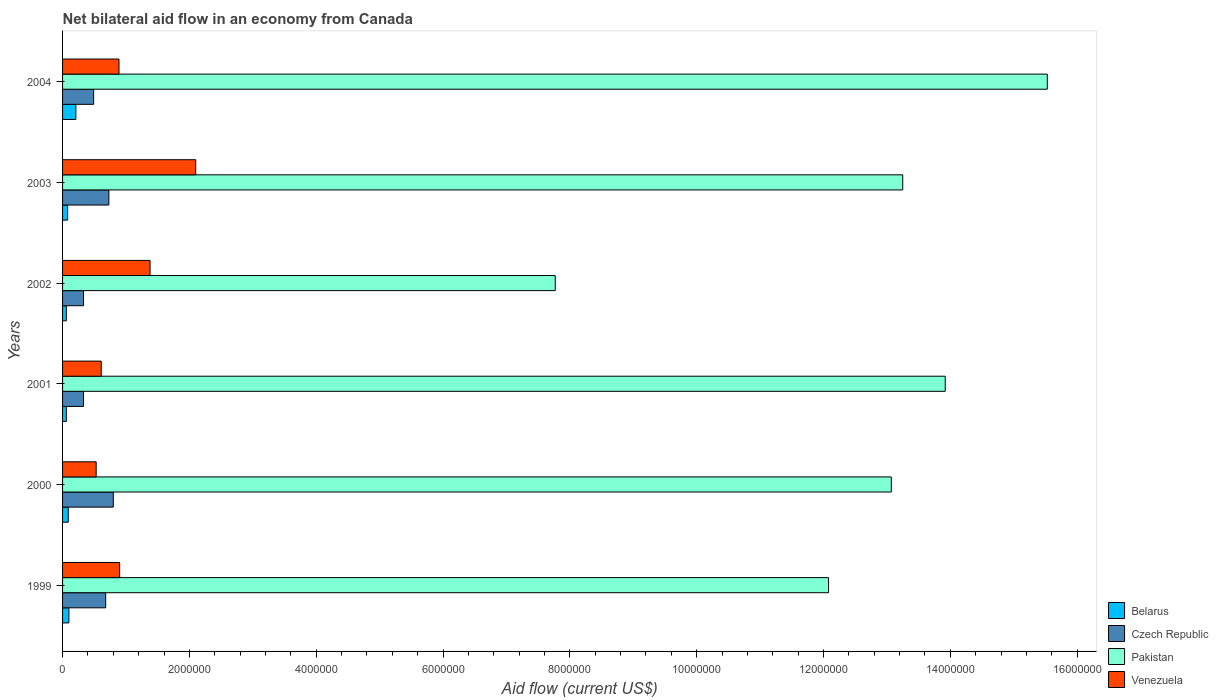How many different coloured bars are there?
Give a very brief answer. 4. Are the number of bars on each tick of the Y-axis equal?
Provide a short and direct response. Yes. How many bars are there on the 3rd tick from the bottom?
Give a very brief answer. 4. What is the label of the 6th group of bars from the top?
Provide a short and direct response. 1999. In how many cases, is the number of bars for a given year not equal to the number of legend labels?
Provide a succinct answer. 0. Across all years, what is the minimum net bilateral aid flow in Venezuela?
Provide a succinct answer. 5.30e+05. What is the total net bilateral aid flow in Belarus in the graph?
Offer a very short reply. 6.00e+05. What is the difference between the net bilateral aid flow in Pakistan in 2002 and that in 2004?
Provide a succinct answer. -7.76e+06. What is the difference between the net bilateral aid flow in Venezuela in 2003 and the net bilateral aid flow in Pakistan in 2002?
Make the answer very short. -5.67e+06. What is the average net bilateral aid flow in Czech Republic per year?
Your answer should be compact. 5.60e+05. In the year 2000, what is the difference between the net bilateral aid flow in Czech Republic and net bilateral aid flow in Belarus?
Make the answer very short. 7.10e+05. In how many years, is the net bilateral aid flow in Czech Republic greater than 9200000 US$?
Make the answer very short. 0. What is the ratio of the net bilateral aid flow in Belarus in 2003 to that in 2004?
Offer a terse response. 0.38. Is the difference between the net bilateral aid flow in Czech Republic in 2003 and 2004 greater than the difference between the net bilateral aid flow in Belarus in 2003 and 2004?
Make the answer very short. Yes. What is the difference between the highest and the second highest net bilateral aid flow in Venezuela?
Your answer should be compact. 7.20e+05. What is the difference between the highest and the lowest net bilateral aid flow in Venezuela?
Make the answer very short. 1.57e+06. In how many years, is the net bilateral aid flow in Czech Republic greater than the average net bilateral aid flow in Czech Republic taken over all years?
Keep it short and to the point. 3. Is it the case that in every year, the sum of the net bilateral aid flow in Belarus and net bilateral aid flow in Venezuela is greater than the sum of net bilateral aid flow in Czech Republic and net bilateral aid flow in Pakistan?
Provide a succinct answer. Yes. What does the 1st bar from the top in 2004 represents?
Your answer should be compact. Venezuela. How many bars are there?
Make the answer very short. 24. Are all the bars in the graph horizontal?
Your response must be concise. Yes. How many years are there in the graph?
Ensure brevity in your answer.  6. What is the difference between two consecutive major ticks on the X-axis?
Offer a very short reply. 2.00e+06. Are the values on the major ticks of X-axis written in scientific E-notation?
Keep it short and to the point. No. Where does the legend appear in the graph?
Offer a very short reply. Bottom right. How many legend labels are there?
Your response must be concise. 4. How are the legend labels stacked?
Provide a succinct answer. Vertical. What is the title of the graph?
Offer a very short reply. Net bilateral aid flow in an economy from Canada. Does "Belarus" appear as one of the legend labels in the graph?
Provide a succinct answer. Yes. What is the label or title of the X-axis?
Keep it short and to the point. Aid flow (current US$). What is the Aid flow (current US$) of Czech Republic in 1999?
Offer a very short reply. 6.80e+05. What is the Aid flow (current US$) in Pakistan in 1999?
Offer a very short reply. 1.21e+07. What is the Aid flow (current US$) in Venezuela in 1999?
Offer a very short reply. 9.00e+05. What is the Aid flow (current US$) of Pakistan in 2000?
Your answer should be compact. 1.31e+07. What is the Aid flow (current US$) in Venezuela in 2000?
Provide a short and direct response. 5.30e+05. What is the Aid flow (current US$) in Czech Republic in 2001?
Provide a succinct answer. 3.30e+05. What is the Aid flow (current US$) of Pakistan in 2001?
Provide a succinct answer. 1.39e+07. What is the Aid flow (current US$) in Belarus in 2002?
Your response must be concise. 6.00e+04. What is the Aid flow (current US$) of Czech Republic in 2002?
Your response must be concise. 3.30e+05. What is the Aid flow (current US$) in Pakistan in 2002?
Your response must be concise. 7.77e+06. What is the Aid flow (current US$) of Venezuela in 2002?
Offer a terse response. 1.38e+06. What is the Aid flow (current US$) of Belarus in 2003?
Offer a very short reply. 8.00e+04. What is the Aid flow (current US$) in Czech Republic in 2003?
Offer a terse response. 7.30e+05. What is the Aid flow (current US$) in Pakistan in 2003?
Offer a very short reply. 1.32e+07. What is the Aid flow (current US$) of Venezuela in 2003?
Your answer should be compact. 2.10e+06. What is the Aid flow (current US$) in Czech Republic in 2004?
Make the answer very short. 4.90e+05. What is the Aid flow (current US$) of Pakistan in 2004?
Provide a short and direct response. 1.55e+07. What is the Aid flow (current US$) of Venezuela in 2004?
Keep it short and to the point. 8.90e+05. Across all years, what is the maximum Aid flow (current US$) in Czech Republic?
Provide a succinct answer. 8.00e+05. Across all years, what is the maximum Aid flow (current US$) of Pakistan?
Your answer should be compact. 1.55e+07. Across all years, what is the maximum Aid flow (current US$) in Venezuela?
Keep it short and to the point. 2.10e+06. Across all years, what is the minimum Aid flow (current US$) of Belarus?
Keep it short and to the point. 6.00e+04. Across all years, what is the minimum Aid flow (current US$) in Czech Republic?
Ensure brevity in your answer.  3.30e+05. Across all years, what is the minimum Aid flow (current US$) of Pakistan?
Keep it short and to the point. 7.77e+06. Across all years, what is the minimum Aid flow (current US$) in Venezuela?
Your response must be concise. 5.30e+05. What is the total Aid flow (current US$) in Belarus in the graph?
Ensure brevity in your answer.  6.00e+05. What is the total Aid flow (current US$) of Czech Republic in the graph?
Provide a succinct answer. 3.36e+06. What is the total Aid flow (current US$) in Pakistan in the graph?
Provide a succinct answer. 7.56e+07. What is the total Aid flow (current US$) in Venezuela in the graph?
Give a very brief answer. 6.41e+06. What is the difference between the Aid flow (current US$) in Pakistan in 1999 and that in 2000?
Provide a short and direct response. -9.90e+05. What is the difference between the Aid flow (current US$) of Venezuela in 1999 and that in 2000?
Make the answer very short. 3.70e+05. What is the difference between the Aid flow (current US$) of Pakistan in 1999 and that in 2001?
Give a very brief answer. -1.84e+06. What is the difference between the Aid flow (current US$) of Venezuela in 1999 and that in 2001?
Your response must be concise. 2.90e+05. What is the difference between the Aid flow (current US$) in Pakistan in 1999 and that in 2002?
Ensure brevity in your answer.  4.31e+06. What is the difference between the Aid flow (current US$) in Venezuela in 1999 and that in 2002?
Your answer should be very brief. -4.80e+05. What is the difference between the Aid flow (current US$) of Pakistan in 1999 and that in 2003?
Offer a very short reply. -1.17e+06. What is the difference between the Aid flow (current US$) of Venezuela in 1999 and that in 2003?
Your answer should be very brief. -1.20e+06. What is the difference between the Aid flow (current US$) in Pakistan in 1999 and that in 2004?
Provide a succinct answer. -3.45e+06. What is the difference between the Aid flow (current US$) in Venezuela in 1999 and that in 2004?
Provide a succinct answer. 10000. What is the difference between the Aid flow (current US$) in Belarus in 2000 and that in 2001?
Your answer should be very brief. 3.00e+04. What is the difference between the Aid flow (current US$) in Pakistan in 2000 and that in 2001?
Ensure brevity in your answer.  -8.50e+05. What is the difference between the Aid flow (current US$) in Pakistan in 2000 and that in 2002?
Your answer should be very brief. 5.30e+06. What is the difference between the Aid flow (current US$) in Venezuela in 2000 and that in 2002?
Your answer should be compact. -8.50e+05. What is the difference between the Aid flow (current US$) of Belarus in 2000 and that in 2003?
Your answer should be very brief. 10000. What is the difference between the Aid flow (current US$) of Venezuela in 2000 and that in 2003?
Offer a terse response. -1.57e+06. What is the difference between the Aid flow (current US$) of Czech Republic in 2000 and that in 2004?
Give a very brief answer. 3.10e+05. What is the difference between the Aid flow (current US$) in Pakistan in 2000 and that in 2004?
Make the answer very short. -2.46e+06. What is the difference between the Aid flow (current US$) in Venezuela in 2000 and that in 2004?
Your answer should be compact. -3.60e+05. What is the difference between the Aid flow (current US$) in Belarus in 2001 and that in 2002?
Your answer should be compact. 0. What is the difference between the Aid flow (current US$) of Pakistan in 2001 and that in 2002?
Keep it short and to the point. 6.15e+06. What is the difference between the Aid flow (current US$) of Venezuela in 2001 and that in 2002?
Offer a terse response. -7.70e+05. What is the difference between the Aid flow (current US$) of Czech Republic in 2001 and that in 2003?
Offer a very short reply. -4.00e+05. What is the difference between the Aid flow (current US$) in Pakistan in 2001 and that in 2003?
Keep it short and to the point. 6.70e+05. What is the difference between the Aid flow (current US$) in Venezuela in 2001 and that in 2003?
Give a very brief answer. -1.49e+06. What is the difference between the Aid flow (current US$) of Belarus in 2001 and that in 2004?
Offer a very short reply. -1.50e+05. What is the difference between the Aid flow (current US$) of Czech Republic in 2001 and that in 2004?
Offer a very short reply. -1.60e+05. What is the difference between the Aid flow (current US$) in Pakistan in 2001 and that in 2004?
Your answer should be very brief. -1.61e+06. What is the difference between the Aid flow (current US$) of Venezuela in 2001 and that in 2004?
Make the answer very short. -2.80e+05. What is the difference between the Aid flow (current US$) of Czech Republic in 2002 and that in 2003?
Make the answer very short. -4.00e+05. What is the difference between the Aid flow (current US$) in Pakistan in 2002 and that in 2003?
Keep it short and to the point. -5.48e+06. What is the difference between the Aid flow (current US$) of Venezuela in 2002 and that in 2003?
Offer a very short reply. -7.20e+05. What is the difference between the Aid flow (current US$) of Pakistan in 2002 and that in 2004?
Offer a terse response. -7.76e+06. What is the difference between the Aid flow (current US$) in Belarus in 2003 and that in 2004?
Offer a terse response. -1.30e+05. What is the difference between the Aid flow (current US$) of Pakistan in 2003 and that in 2004?
Your answer should be compact. -2.28e+06. What is the difference between the Aid flow (current US$) in Venezuela in 2003 and that in 2004?
Provide a short and direct response. 1.21e+06. What is the difference between the Aid flow (current US$) in Belarus in 1999 and the Aid flow (current US$) in Czech Republic in 2000?
Make the answer very short. -7.00e+05. What is the difference between the Aid flow (current US$) of Belarus in 1999 and the Aid flow (current US$) of Pakistan in 2000?
Offer a very short reply. -1.30e+07. What is the difference between the Aid flow (current US$) of Belarus in 1999 and the Aid flow (current US$) of Venezuela in 2000?
Make the answer very short. -4.30e+05. What is the difference between the Aid flow (current US$) of Czech Republic in 1999 and the Aid flow (current US$) of Pakistan in 2000?
Offer a very short reply. -1.24e+07. What is the difference between the Aid flow (current US$) of Pakistan in 1999 and the Aid flow (current US$) of Venezuela in 2000?
Keep it short and to the point. 1.16e+07. What is the difference between the Aid flow (current US$) of Belarus in 1999 and the Aid flow (current US$) of Czech Republic in 2001?
Your answer should be compact. -2.30e+05. What is the difference between the Aid flow (current US$) in Belarus in 1999 and the Aid flow (current US$) in Pakistan in 2001?
Offer a very short reply. -1.38e+07. What is the difference between the Aid flow (current US$) of Belarus in 1999 and the Aid flow (current US$) of Venezuela in 2001?
Keep it short and to the point. -5.10e+05. What is the difference between the Aid flow (current US$) in Czech Republic in 1999 and the Aid flow (current US$) in Pakistan in 2001?
Offer a very short reply. -1.32e+07. What is the difference between the Aid flow (current US$) in Pakistan in 1999 and the Aid flow (current US$) in Venezuela in 2001?
Offer a very short reply. 1.15e+07. What is the difference between the Aid flow (current US$) in Belarus in 1999 and the Aid flow (current US$) in Czech Republic in 2002?
Make the answer very short. -2.30e+05. What is the difference between the Aid flow (current US$) of Belarus in 1999 and the Aid flow (current US$) of Pakistan in 2002?
Your answer should be very brief. -7.67e+06. What is the difference between the Aid flow (current US$) in Belarus in 1999 and the Aid flow (current US$) in Venezuela in 2002?
Offer a terse response. -1.28e+06. What is the difference between the Aid flow (current US$) of Czech Republic in 1999 and the Aid flow (current US$) of Pakistan in 2002?
Ensure brevity in your answer.  -7.09e+06. What is the difference between the Aid flow (current US$) of Czech Republic in 1999 and the Aid flow (current US$) of Venezuela in 2002?
Your answer should be very brief. -7.00e+05. What is the difference between the Aid flow (current US$) in Pakistan in 1999 and the Aid flow (current US$) in Venezuela in 2002?
Ensure brevity in your answer.  1.07e+07. What is the difference between the Aid flow (current US$) in Belarus in 1999 and the Aid flow (current US$) in Czech Republic in 2003?
Make the answer very short. -6.30e+05. What is the difference between the Aid flow (current US$) of Belarus in 1999 and the Aid flow (current US$) of Pakistan in 2003?
Your response must be concise. -1.32e+07. What is the difference between the Aid flow (current US$) in Czech Republic in 1999 and the Aid flow (current US$) in Pakistan in 2003?
Offer a terse response. -1.26e+07. What is the difference between the Aid flow (current US$) in Czech Republic in 1999 and the Aid flow (current US$) in Venezuela in 2003?
Make the answer very short. -1.42e+06. What is the difference between the Aid flow (current US$) in Pakistan in 1999 and the Aid flow (current US$) in Venezuela in 2003?
Your answer should be very brief. 9.98e+06. What is the difference between the Aid flow (current US$) of Belarus in 1999 and the Aid flow (current US$) of Czech Republic in 2004?
Keep it short and to the point. -3.90e+05. What is the difference between the Aid flow (current US$) in Belarus in 1999 and the Aid flow (current US$) in Pakistan in 2004?
Offer a terse response. -1.54e+07. What is the difference between the Aid flow (current US$) of Belarus in 1999 and the Aid flow (current US$) of Venezuela in 2004?
Give a very brief answer. -7.90e+05. What is the difference between the Aid flow (current US$) of Czech Republic in 1999 and the Aid flow (current US$) of Pakistan in 2004?
Make the answer very short. -1.48e+07. What is the difference between the Aid flow (current US$) of Pakistan in 1999 and the Aid flow (current US$) of Venezuela in 2004?
Ensure brevity in your answer.  1.12e+07. What is the difference between the Aid flow (current US$) of Belarus in 2000 and the Aid flow (current US$) of Czech Republic in 2001?
Your response must be concise. -2.40e+05. What is the difference between the Aid flow (current US$) of Belarus in 2000 and the Aid flow (current US$) of Pakistan in 2001?
Your answer should be compact. -1.38e+07. What is the difference between the Aid flow (current US$) in Belarus in 2000 and the Aid flow (current US$) in Venezuela in 2001?
Offer a terse response. -5.20e+05. What is the difference between the Aid flow (current US$) of Czech Republic in 2000 and the Aid flow (current US$) of Pakistan in 2001?
Your answer should be very brief. -1.31e+07. What is the difference between the Aid flow (current US$) in Pakistan in 2000 and the Aid flow (current US$) in Venezuela in 2001?
Give a very brief answer. 1.25e+07. What is the difference between the Aid flow (current US$) of Belarus in 2000 and the Aid flow (current US$) of Pakistan in 2002?
Offer a very short reply. -7.68e+06. What is the difference between the Aid flow (current US$) of Belarus in 2000 and the Aid flow (current US$) of Venezuela in 2002?
Make the answer very short. -1.29e+06. What is the difference between the Aid flow (current US$) of Czech Republic in 2000 and the Aid flow (current US$) of Pakistan in 2002?
Ensure brevity in your answer.  -6.97e+06. What is the difference between the Aid flow (current US$) of Czech Republic in 2000 and the Aid flow (current US$) of Venezuela in 2002?
Offer a very short reply. -5.80e+05. What is the difference between the Aid flow (current US$) in Pakistan in 2000 and the Aid flow (current US$) in Venezuela in 2002?
Offer a very short reply. 1.17e+07. What is the difference between the Aid flow (current US$) of Belarus in 2000 and the Aid flow (current US$) of Czech Republic in 2003?
Your answer should be very brief. -6.40e+05. What is the difference between the Aid flow (current US$) in Belarus in 2000 and the Aid flow (current US$) in Pakistan in 2003?
Give a very brief answer. -1.32e+07. What is the difference between the Aid flow (current US$) of Belarus in 2000 and the Aid flow (current US$) of Venezuela in 2003?
Offer a terse response. -2.01e+06. What is the difference between the Aid flow (current US$) of Czech Republic in 2000 and the Aid flow (current US$) of Pakistan in 2003?
Provide a succinct answer. -1.24e+07. What is the difference between the Aid flow (current US$) in Czech Republic in 2000 and the Aid flow (current US$) in Venezuela in 2003?
Offer a terse response. -1.30e+06. What is the difference between the Aid flow (current US$) of Pakistan in 2000 and the Aid flow (current US$) of Venezuela in 2003?
Ensure brevity in your answer.  1.10e+07. What is the difference between the Aid flow (current US$) in Belarus in 2000 and the Aid flow (current US$) in Czech Republic in 2004?
Offer a very short reply. -4.00e+05. What is the difference between the Aid flow (current US$) in Belarus in 2000 and the Aid flow (current US$) in Pakistan in 2004?
Make the answer very short. -1.54e+07. What is the difference between the Aid flow (current US$) in Belarus in 2000 and the Aid flow (current US$) in Venezuela in 2004?
Keep it short and to the point. -8.00e+05. What is the difference between the Aid flow (current US$) in Czech Republic in 2000 and the Aid flow (current US$) in Pakistan in 2004?
Offer a very short reply. -1.47e+07. What is the difference between the Aid flow (current US$) of Czech Republic in 2000 and the Aid flow (current US$) of Venezuela in 2004?
Keep it short and to the point. -9.00e+04. What is the difference between the Aid flow (current US$) in Pakistan in 2000 and the Aid flow (current US$) in Venezuela in 2004?
Your answer should be very brief. 1.22e+07. What is the difference between the Aid flow (current US$) of Belarus in 2001 and the Aid flow (current US$) of Pakistan in 2002?
Your response must be concise. -7.71e+06. What is the difference between the Aid flow (current US$) in Belarus in 2001 and the Aid flow (current US$) in Venezuela in 2002?
Offer a very short reply. -1.32e+06. What is the difference between the Aid flow (current US$) of Czech Republic in 2001 and the Aid flow (current US$) of Pakistan in 2002?
Make the answer very short. -7.44e+06. What is the difference between the Aid flow (current US$) of Czech Republic in 2001 and the Aid flow (current US$) of Venezuela in 2002?
Your answer should be compact. -1.05e+06. What is the difference between the Aid flow (current US$) of Pakistan in 2001 and the Aid flow (current US$) of Venezuela in 2002?
Offer a very short reply. 1.25e+07. What is the difference between the Aid flow (current US$) of Belarus in 2001 and the Aid flow (current US$) of Czech Republic in 2003?
Provide a short and direct response. -6.70e+05. What is the difference between the Aid flow (current US$) in Belarus in 2001 and the Aid flow (current US$) in Pakistan in 2003?
Ensure brevity in your answer.  -1.32e+07. What is the difference between the Aid flow (current US$) in Belarus in 2001 and the Aid flow (current US$) in Venezuela in 2003?
Provide a short and direct response. -2.04e+06. What is the difference between the Aid flow (current US$) of Czech Republic in 2001 and the Aid flow (current US$) of Pakistan in 2003?
Ensure brevity in your answer.  -1.29e+07. What is the difference between the Aid flow (current US$) in Czech Republic in 2001 and the Aid flow (current US$) in Venezuela in 2003?
Your answer should be very brief. -1.77e+06. What is the difference between the Aid flow (current US$) of Pakistan in 2001 and the Aid flow (current US$) of Venezuela in 2003?
Give a very brief answer. 1.18e+07. What is the difference between the Aid flow (current US$) of Belarus in 2001 and the Aid flow (current US$) of Czech Republic in 2004?
Keep it short and to the point. -4.30e+05. What is the difference between the Aid flow (current US$) in Belarus in 2001 and the Aid flow (current US$) in Pakistan in 2004?
Keep it short and to the point. -1.55e+07. What is the difference between the Aid flow (current US$) in Belarus in 2001 and the Aid flow (current US$) in Venezuela in 2004?
Your answer should be compact. -8.30e+05. What is the difference between the Aid flow (current US$) of Czech Republic in 2001 and the Aid flow (current US$) of Pakistan in 2004?
Ensure brevity in your answer.  -1.52e+07. What is the difference between the Aid flow (current US$) of Czech Republic in 2001 and the Aid flow (current US$) of Venezuela in 2004?
Offer a very short reply. -5.60e+05. What is the difference between the Aid flow (current US$) of Pakistan in 2001 and the Aid flow (current US$) of Venezuela in 2004?
Offer a terse response. 1.30e+07. What is the difference between the Aid flow (current US$) in Belarus in 2002 and the Aid flow (current US$) in Czech Republic in 2003?
Provide a short and direct response. -6.70e+05. What is the difference between the Aid flow (current US$) of Belarus in 2002 and the Aid flow (current US$) of Pakistan in 2003?
Your answer should be compact. -1.32e+07. What is the difference between the Aid flow (current US$) in Belarus in 2002 and the Aid flow (current US$) in Venezuela in 2003?
Offer a terse response. -2.04e+06. What is the difference between the Aid flow (current US$) of Czech Republic in 2002 and the Aid flow (current US$) of Pakistan in 2003?
Make the answer very short. -1.29e+07. What is the difference between the Aid flow (current US$) in Czech Republic in 2002 and the Aid flow (current US$) in Venezuela in 2003?
Provide a short and direct response. -1.77e+06. What is the difference between the Aid flow (current US$) of Pakistan in 2002 and the Aid flow (current US$) of Venezuela in 2003?
Your answer should be compact. 5.67e+06. What is the difference between the Aid flow (current US$) in Belarus in 2002 and the Aid flow (current US$) in Czech Republic in 2004?
Your answer should be very brief. -4.30e+05. What is the difference between the Aid flow (current US$) of Belarus in 2002 and the Aid flow (current US$) of Pakistan in 2004?
Provide a succinct answer. -1.55e+07. What is the difference between the Aid flow (current US$) of Belarus in 2002 and the Aid flow (current US$) of Venezuela in 2004?
Make the answer very short. -8.30e+05. What is the difference between the Aid flow (current US$) in Czech Republic in 2002 and the Aid flow (current US$) in Pakistan in 2004?
Provide a short and direct response. -1.52e+07. What is the difference between the Aid flow (current US$) in Czech Republic in 2002 and the Aid flow (current US$) in Venezuela in 2004?
Your answer should be very brief. -5.60e+05. What is the difference between the Aid flow (current US$) of Pakistan in 2002 and the Aid flow (current US$) of Venezuela in 2004?
Offer a very short reply. 6.88e+06. What is the difference between the Aid flow (current US$) of Belarus in 2003 and the Aid flow (current US$) of Czech Republic in 2004?
Your answer should be compact. -4.10e+05. What is the difference between the Aid flow (current US$) of Belarus in 2003 and the Aid flow (current US$) of Pakistan in 2004?
Offer a terse response. -1.54e+07. What is the difference between the Aid flow (current US$) in Belarus in 2003 and the Aid flow (current US$) in Venezuela in 2004?
Give a very brief answer. -8.10e+05. What is the difference between the Aid flow (current US$) in Czech Republic in 2003 and the Aid flow (current US$) in Pakistan in 2004?
Provide a succinct answer. -1.48e+07. What is the difference between the Aid flow (current US$) of Pakistan in 2003 and the Aid flow (current US$) of Venezuela in 2004?
Give a very brief answer. 1.24e+07. What is the average Aid flow (current US$) of Czech Republic per year?
Offer a very short reply. 5.60e+05. What is the average Aid flow (current US$) of Pakistan per year?
Your answer should be very brief. 1.26e+07. What is the average Aid flow (current US$) in Venezuela per year?
Offer a very short reply. 1.07e+06. In the year 1999, what is the difference between the Aid flow (current US$) in Belarus and Aid flow (current US$) in Czech Republic?
Your response must be concise. -5.80e+05. In the year 1999, what is the difference between the Aid flow (current US$) of Belarus and Aid flow (current US$) of Pakistan?
Ensure brevity in your answer.  -1.20e+07. In the year 1999, what is the difference between the Aid flow (current US$) in Belarus and Aid flow (current US$) in Venezuela?
Ensure brevity in your answer.  -8.00e+05. In the year 1999, what is the difference between the Aid flow (current US$) in Czech Republic and Aid flow (current US$) in Pakistan?
Ensure brevity in your answer.  -1.14e+07. In the year 1999, what is the difference between the Aid flow (current US$) of Czech Republic and Aid flow (current US$) of Venezuela?
Offer a terse response. -2.20e+05. In the year 1999, what is the difference between the Aid flow (current US$) of Pakistan and Aid flow (current US$) of Venezuela?
Provide a short and direct response. 1.12e+07. In the year 2000, what is the difference between the Aid flow (current US$) of Belarus and Aid flow (current US$) of Czech Republic?
Give a very brief answer. -7.10e+05. In the year 2000, what is the difference between the Aid flow (current US$) in Belarus and Aid flow (current US$) in Pakistan?
Keep it short and to the point. -1.30e+07. In the year 2000, what is the difference between the Aid flow (current US$) in Belarus and Aid flow (current US$) in Venezuela?
Your answer should be compact. -4.40e+05. In the year 2000, what is the difference between the Aid flow (current US$) of Czech Republic and Aid flow (current US$) of Pakistan?
Your answer should be compact. -1.23e+07. In the year 2000, what is the difference between the Aid flow (current US$) in Czech Republic and Aid flow (current US$) in Venezuela?
Ensure brevity in your answer.  2.70e+05. In the year 2000, what is the difference between the Aid flow (current US$) in Pakistan and Aid flow (current US$) in Venezuela?
Provide a short and direct response. 1.25e+07. In the year 2001, what is the difference between the Aid flow (current US$) in Belarus and Aid flow (current US$) in Czech Republic?
Make the answer very short. -2.70e+05. In the year 2001, what is the difference between the Aid flow (current US$) in Belarus and Aid flow (current US$) in Pakistan?
Offer a terse response. -1.39e+07. In the year 2001, what is the difference between the Aid flow (current US$) in Belarus and Aid flow (current US$) in Venezuela?
Keep it short and to the point. -5.50e+05. In the year 2001, what is the difference between the Aid flow (current US$) of Czech Republic and Aid flow (current US$) of Pakistan?
Offer a very short reply. -1.36e+07. In the year 2001, what is the difference between the Aid flow (current US$) of Czech Republic and Aid flow (current US$) of Venezuela?
Ensure brevity in your answer.  -2.80e+05. In the year 2001, what is the difference between the Aid flow (current US$) in Pakistan and Aid flow (current US$) in Venezuela?
Give a very brief answer. 1.33e+07. In the year 2002, what is the difference between the Aid flow (current US$) of Belarus and Aid flow (current US$) of Czech Republic?
Keep it short and to the point. -2.70e+05. In the year 2002, what is the difference between the Aid flow (current US$) of Belarus and Aid flow (current US$) of Pakistan?
Your response must be concise. -7.71e+06. In the year 2002, what is the difference between the Aid flow (current US$) in Belarus and Aid flow (current US$) in Venezuela?
Ensure brevity in your answer.  -1.32e+06. In the year 2002, what is the difference between the Aid flow (current US$) in Czech Republic and Aid flow (current US$) in Pakistan?
Keep it short and to the point. -7.44e+06. In the year 2002, what is the difference between the Aid flow (current US$) of Czech Republic and Aid flow (current US$) of Venezuela?
Your answer should be compact. -1.05e+06. In the year 2002, what is the difference between the Aid flow (current US$) in Pakistan and Aid flow (current US$) in Venezuela?
Provide a succinct answer. 6.39e+06. In the year 2003, what is the difference between the Aid flow (current US$) of Belarus and Aid flow (current US$) of Czech Republic?
Offer a terse response. -6.50e+05. In the year 2003, what is the difference between the Aid flow (current US$) of Belarus and Aid flow (current US$) of Pakistan?
Keep it short and to the point. -1.32e+07. In the year 2003, what is the difference between the Aid flow (current US$) in Belarus and Aid flow (current US$) in Venezuela?
Provide a succinct answer. -2.02e+06. In the year 2003, what is the difference between the Aid flow (current US$) in Czech Republic and Aid flow (current US$) in Pakistan?
Provide a short and direct response. -1.25e+07. In the year 2003, what is the difference between the Aid flow (current US$) in Czech Republic and Aid flow (current US$) in Venezuela?
Your answer should be very brief. -1.37e+06. In the year 2003, what is the difference between the Aid flow (current US$) of Pakistan and Aid flow (current US$) of Venezuela?
Your answer should be compact. 1.12e+07. In the year 2004, what is the difference between the Aid flow (current US$) of Belarus and Aid flow (current US$) of Czech Republic?
Provide a succinct answer. -2.80e+05. In the year 2004, what is the difference between the Aid flow (current US$) of Belarus and Aid flow (current US$) of Pakistan?
Offer a very short reply. -1.53e+07. In the year 2004, what is the difference between the Aid flow (current US$) in Belarus and Aid flow (current US$) in Venezuela?
Your answer should be very brief. -6.80e+05. In the year 2004, what is the difference between the Aid flow (current US$) in Czech Republic and Aid flow (current US$) in Pakistan?
Provide a short and direct response. -1.50e+07. In the year 2004, what is the difference between the Aid flow (current US$) of Czech Republic and Aid flow (current US$) of Venezuela?
Offer a very short reply. -4.00e+05. In the year 2004, what is the difference between the Aid flow (current US$) of Pakistan and Aid flow (current US$) of Venezuela?
Ensure brevity in your answer.  1.46e+07. What is the ratio of the Aid flow (current US$) in Belarus in 1999 to that in 2000?
Keep it short and to the point. 1.11. What is the ratio of the Aid flow (current US$) in Czech Republic in 1999 to that in 2000?
Offer a very short reply. 0.85. What is the ratio of the Aid flow (current US$) of Pakistan in 1999 to that in 2000?
Keep it short and to the point. 0.92. What is the ratio of the Aid flow (current US$) of Venezuela in 1999 to that in 2000?
Provide a short and direct response. 1.7. What is the ratio of the Aid flow (current US$) of Czech Republic in 1999 to that in 2001?
Give a very brief answer. 2.06. What is the ratio of the Aid flow (current US$) in Pakistan in 1999 to that in 2001?
Offer a very short reply. 0.87. What is the ratio of the Aid flow (current US$) of Venezuela in 1999 to that in 2001?
Provide a succinct answer. 1.48. What is the ratio of the Aid flow (current US$) in Belarus in 1999 to that in 2002?
Make the answer very short. 1.67. What is the ratio of the Aid flow (current US$) of Czech Republic in 1999 to that in 2002?
Give a very brief answer. 2.06. What is the ratio of the Aid flow (current US$) in Pakistan in 1999 to that in 2002?
Make the answer very short. 1.55. What is the ratio of the Aid flow (current US$) of Venezuela in 1999 to that in 2002?
Offer a terse response. 0.65. What is the ratio of the Aid flow (current US$) of Czech Republic in 1999 to that in 2003?
Ensure brevity in your answer.  0.93. What is the ratio of the Aid flow (current US$) of Pakistan in 1999 to that in 2003?
Keep it short and to the point. 0.91. What is the ratio of the Aid flow (current US$) in Venezuela in 1999 to that in 2003?
Provide a succinct answer. 0.43. What is the ratio of the Aid flow (current US$) of Belarus in 1999 to that in 2004?
Offer a very short reply. 0.48. What is the ratio of the Aid flow (current US$) of Czech Republic in 1999 to that in 2004?
Offer a terse response. 1.39. What is the ratio of the Aid flow (current US$) in Venezuela in 1999 to that in 2004?
Offer a very short reply. 1.01. What is the ratio of the Aid flow (current US$) of Czech Republic in 2000 to that in 2001?
Keep it short and to the point. 2.42. What is the ratio of the Aid flow (current US$) in Pakistan in 2000 to that in 2001?
Your answer should be compact. 0.94. What is the ratio of the Aid flow (current US$) in Venezuela in 2000 to that in 2001?
Keep it short and to the point. 0.87. What is the ratio of the Aid flow (current US$) of Czech Republic in 2000 to that in 2002?
Give a very brief answer. 2.42. What is the ratio of the Aid flow (current US$) in Pakistan in 2000 to that in 2002?
Ensure brevity in your answer.  1.68. What is the ratio of the Aid flow (current US$) in Venezuela in 2000 to that in 2002?
Provide a short and direct response. 0.38. What is the ratio of the Aid flow (current US$) in Czech Republic in 2000 to that in 2003?
Keep it short and to the point. 1.1. What is the ratio of the Aid flow (current US$) of Pakistan in 2000 to that in 2003?
Make the answer very short. 0.99. What is the ratio of the Aid flow (current US$) in Venezuela in 2000 to that in 2003?
Keep it short and to the point. 0.25. What is the ratio of the Aid flow (current US$) in Belarus in 2000 to that in 2004?
Ensure brevity in your answer.  0.43. What is the ratio of the Aid flow (current US$) in Czech Republic in 2000 to that in 2004?
Offer a very short reply. 1.63. What is the ratio of the Aid flow (current US$) in Pakistan in 2000 to that in 2004?
Give a very brief answer. 0.84. What is the ratio of the Aid flow (current US$) of Venezuela in 2000 to that in 2004?
Keep it short and to the point. 0.6. What is the ratio of the Aid flow (current US$) of Belarus in 2001 to that in 2002?
Make the answer very short. 1. What is the ratio of the Aid flow (current US$) in Pakistan in 2001 to that in 2002?
Your answer should be very brief. 1.79. What is the ratio of the Aid flow (current US$) of Venezuela in 2001 to that in 2002?
Keep it short and to the point. 0.44. What is the ratio of the Aid flow (current US$) of Czech Republic in 2001 to that in 2003?
Offer a terse response. 0.45. What is the ratio of the Aid flow (current US$) of Pakistan in 2001 to that in 2003?
Your response must be concise. 1.05. What is the ratio of the Aid flow (current US$) in Venezuela in 2001 to that in 2003?
Make the answer very short. 0.29. What is the ratio of the Aid flow (current US$) in Belarus in 2001 to that in 2004?
Your response must be concise. 0.29. What is the ratio of the Aid flow (current US$) in Czech Republic in 2001 to that in 2004?
Your response must be concise. 0.67. What is the ratio of the Aid flow (current US$) of Pakistan in 2001 to that in 2004?
Offer a terse response. 0.9. What is the ratio of the Aid flow (current US$) in Venezuela in 2001 to that in 2004?
Your answer should be compact. 0.69. What is the ratio of the Aid flow (current US$) of Belarus in 2002 to that in 2003?
Offer a very short reply. 0.75. What is the ratio of the Aid flow (current US$) of Czech Republic in 2002 to that in 2003?
Provide a succinct answer. 0.45. What is the ratio of the Aid flow (current US$) of Pakistan in 2002 to that in 2003?
Ensure brevity in your answer.  0.59. What is the ratio of the Aid flow (current US$) of Venezuela in 2002 to that in 2003?
Your answer should be very brief. 0.66. What is the ratio of the Aid flow (current US$) of Belarus in 2002 to that in 2004?
Offer a terse response. 0.29. What is the ratio of the Aid flow (current US$) of Czech Republic in 2002 to that in 2004?
Provide a succinct answer. 0.67. What is the ratio of the Aid flow (current US$) in Pakistan in 2002 to that in 2004?
Offer a very short reply. 0.5. What is the ratio of the Aid flow (current US$) in Venezuela in 2002 to that in 2004?
Keep it short and to the point. 1.55. What is the ratio of the Aid flow (current US$) of Belarus in 2003 to that in 2004?
Ensure brevity in your answer.  0.38. What is the ratio of the Aid flow (current US$) in Czech Republic in 2003 to that in 2004?
Provide a succinct answer. 1.49. What is the ratio of the Aid flow (current US$) of Pakistan in 2003 to that in 2004?
Your answer should be compact. 0.85. What is the ratio of the Aid flow (current US$) in Venezuela in 2003 to that in 2004?
Your answer should be very brief. 2.36. What is the difference between the highest and the second highest Aid flow (current US$) of Pakistan?
Your answer should be very brief. 1.61e+06. What is the difference between the highest and the second highest Aid flow (current US$) in Venezuela?
Provide a short and direct response. 7.20e+05. What is the difference between the highest and the lowest Aid flow (current US$) of Belarus?
Give a very brief answer. 1.50e+05. What is the difference between the highest and the lowest Aid flow (current US$) of Pakistan?
Give a very brief answer. 7.76e+06. What is the difference between the highest and the lowest Aid flow (current US$) of Venezuela?
Offer a very short reply. 1.57e+06. 